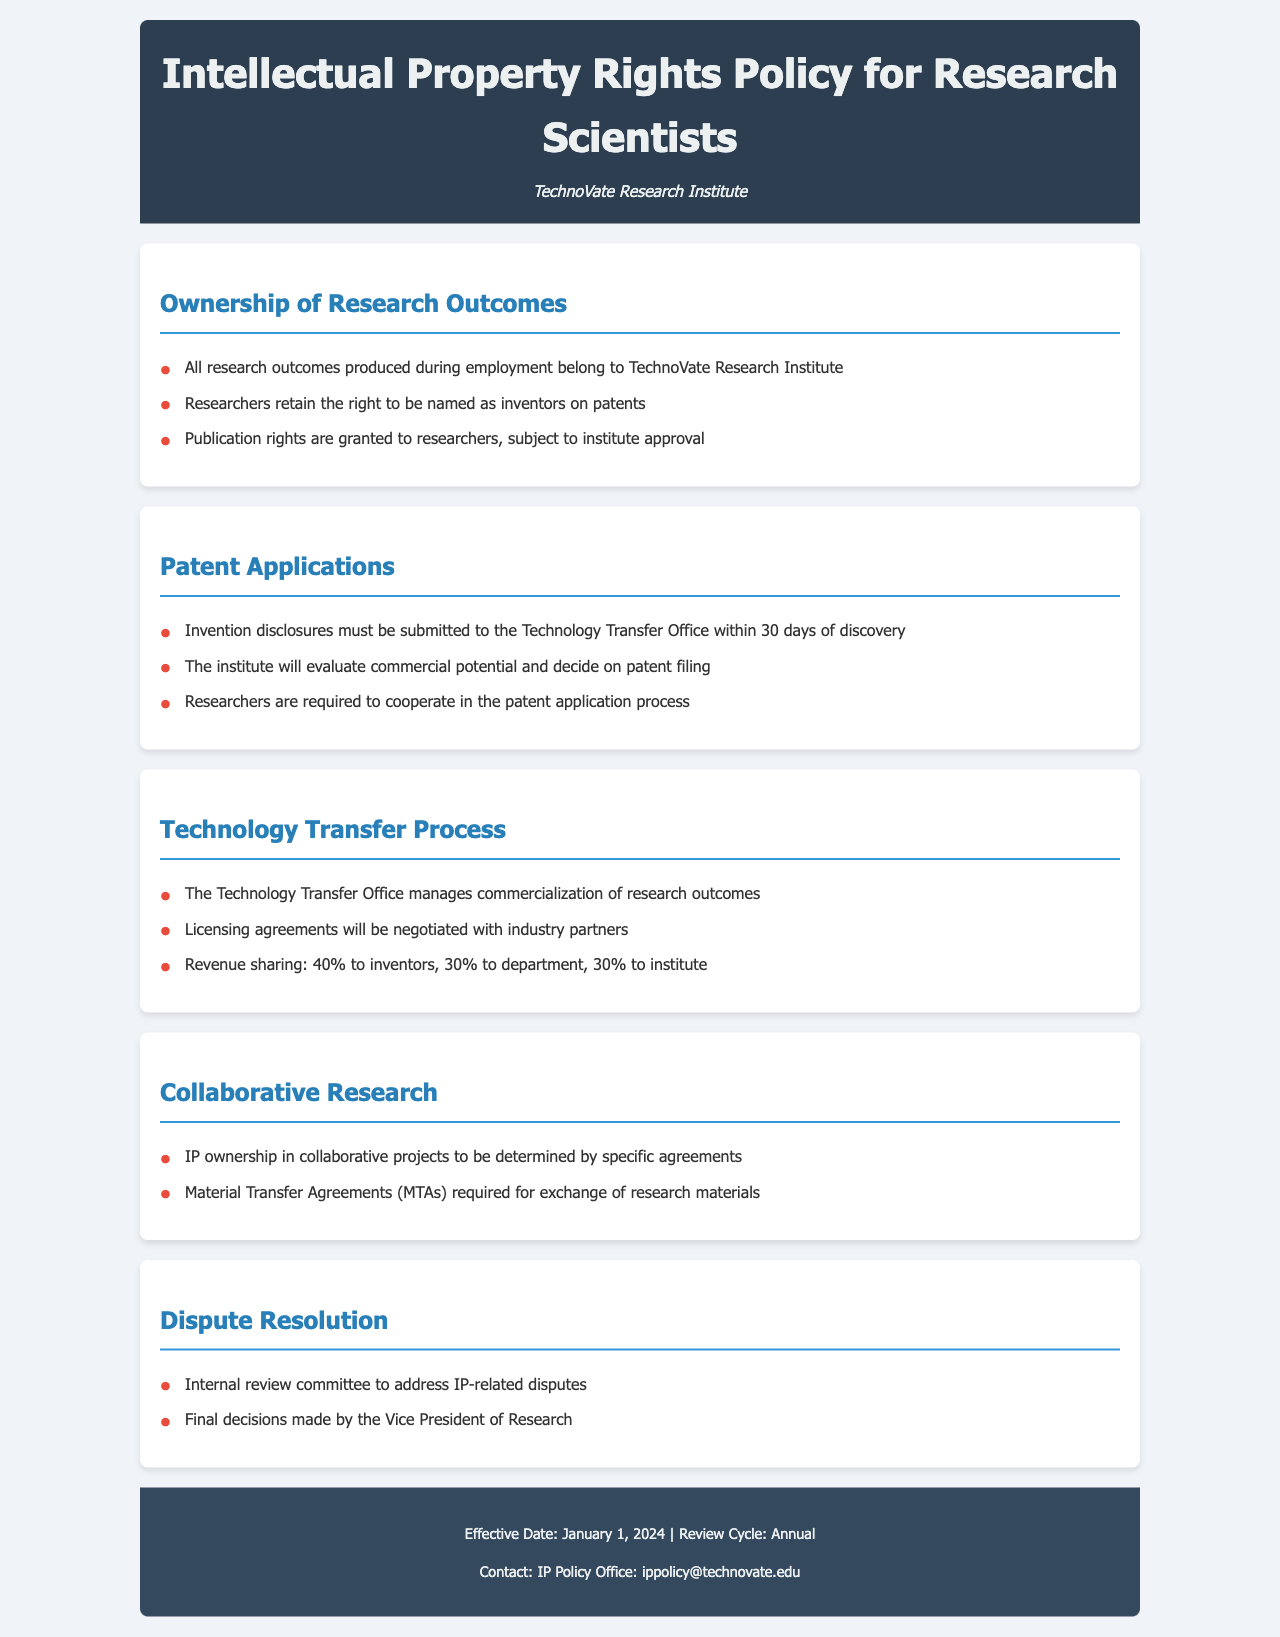What is the name of the institute? The name of the institute is mentioned in the header of the document as the organization responsible for the policy.
Answer: TechnoVate Research Institute What percentage of revenue goes to inventors? The document specifies the revenue sharing model and the portion allocated to inventors.
Answer: 40% What must researchers submit within 30 days of discovery? The document outlines a specific requirement that researchers need to follow concerning their inventions.
Answer: Invention disclosures Who makes the final decisions on IP-related disputes? The document states who has the authority to make the final call in case of disputes related to intellectual property.
Answer: Vice President of Research What is required for the exchange of research materials? The document specifies an agreement necessary for sharing materials in collaborative projects.
Answer: Material Transfer Agreements What rights do researchers retain concerning patents? The document mentions the rights that researchers have concerning their contributions to patents.
Answer: To be named as inventors Which office manages the commercialization of research outcomes? The document identifies the office responsible for handling the commercialization processes.
Answer: Technology Transfer Office What is the review cycle for the policy? The document provides information on how frequently the policy is reviewed.
Answer: Annual 